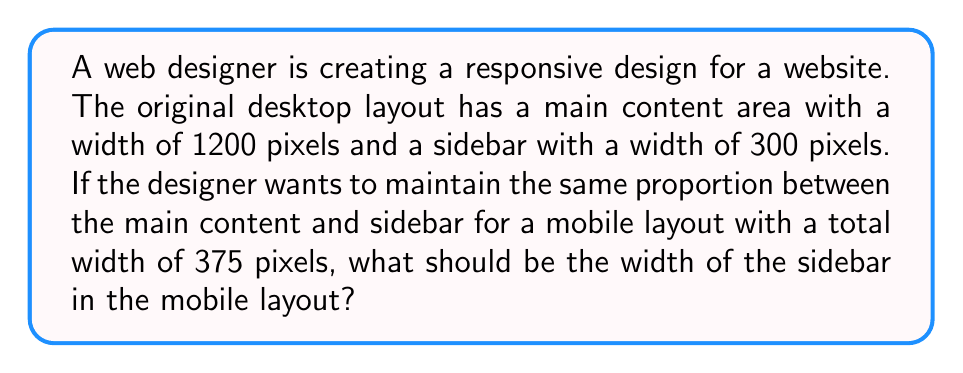Give your solution to this math problem. Let's approach this step-by-step:

1) First, we need to determine the ratio between the main content and sidebar in the desktop layout:
   Main content : Sidebar = 1200 : 300

2) Simplify this ratio:
   1200 : 300 = 4 : 1

3) Now, we know that the total width of the mobile layout is 375 pixels. We need to divide this into parts that maintain the 4:1 ratio.

4) Let's represent the sidebar width as $x$. Then the main content width will be $4x$.

5) The total width equation:
   $x + 4x = 375$
   $5x = 375$

6) Solve for $x$:
   $x = 375 \div 5 = 75$

7) Therefore, the sidebar width in the mobile layout should be 75 pixels.

8) We can verify:
   Main content: $4 * 75 = 300$ pixels
   Sidebar: $75$ pixels
   Total: $300 + 75 = 375$ pixels

This maintains the 4:1 ratio while fitting the 375-pixel mobile layout.
Answer: 75 pixels 